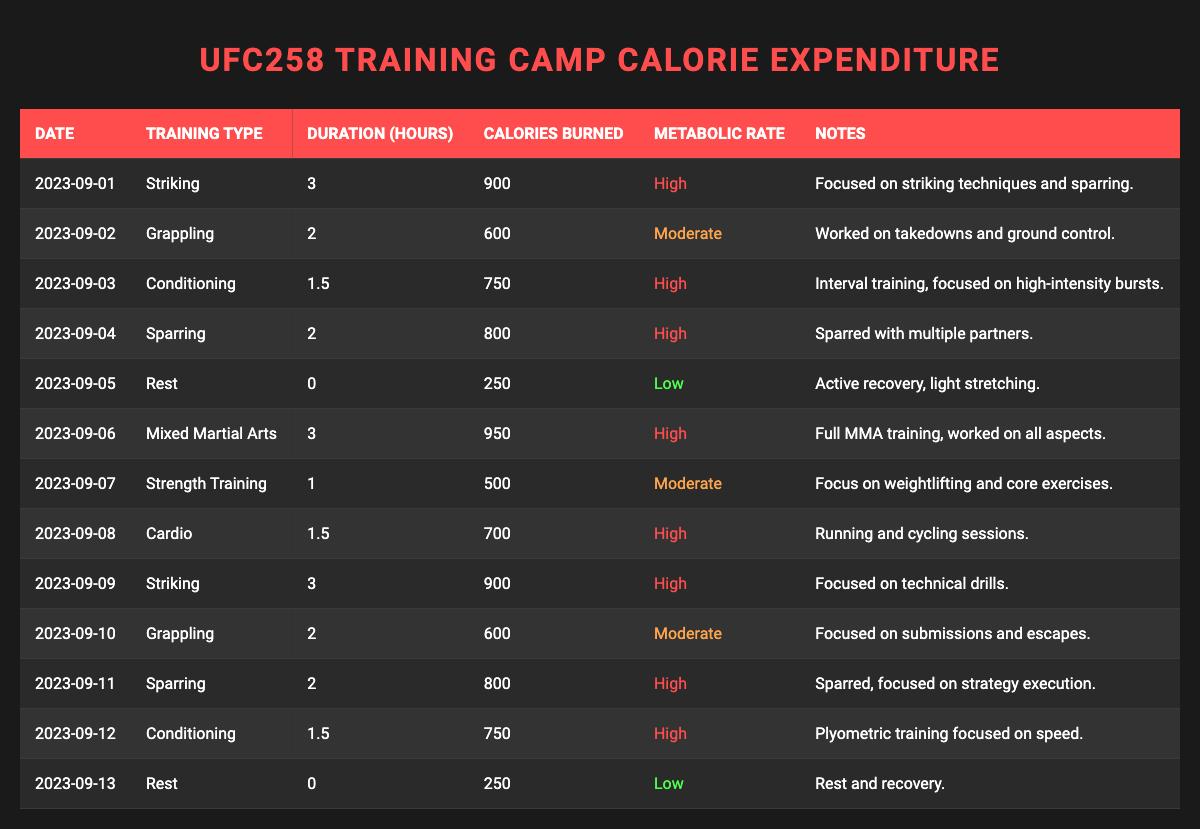What was the total calories burned during the training camp? To find the total calories burned, sum up the "Calories Burned" values for each training session from September 1 to September 13. The total is: 900 + 600 + 750 + 800 + 250 + 950 + 500 + 700 + 900 + 600 + 800 + 750 + 250 = 8550 calories.
Answer: 8550 calories Which training type had the highest calorie expenditure? The "Mixed Martial Arts" training on September 6 had the highest calorie expenditure at 950 calories. No other training session burned more calories than this.
Answer: Mixed Martial Arts How many days involved rest during the training camp? Looking at the "Training Type" column, there are two entries where the training type is "Rest" (September 5 and September 13). Therefore, there were 2 days of rest.
Answer: 2 days What was the average number of calories burned per training day? To calculate the average, sum all calories burned (8550) and divide by the number of training days (11, excluding rest days) which gives us 8550 / 11 ≈ 778.18.
Answer: Approximately 778 calories Did any day involve both high metabolic rate training and rest? No, the table shows that high metabolic rate training sessions occurred on September 1, 3, 4, 6, 8, 9, 11, and 12, while rest days occurred separately on September 5 and 13, indicating no overlap.
Answer: No What is the total duration of high-intensity training sessions in the camp? The total duration of high-intensity sessions includes 3 (Striking) + 1.5 (Conditioning) + 2 (Sparring) + 3 (Mixed Martial Arts) + 1.5 (Cardio) + 3 (Striking) + 2 (Sparring) + 1.5 (Conditioning) = 14.5 hours in high-intensity sessions.
Answer: 14.5 hours Which day had the lowest calories burned and what was the amount? The day with the lowest calories burned was September 5 with 250 calories during a Rest day.
Answer: 250 calories What percentage of the days had a high metabolic rate? There are 8 days with high metabolic rate training out of a total of 13 days (including rest). To get the percentage, (8 / 13) * 100 ≈ 61.54%.
Answer: Approximately 61.5% How many training types were listed in the data, and which one had the lowest calorie expenditure? The training types listed are Striking, Grappling, Conditioning, Sparring, Rest, Mixed Martial Arts, Strength Training, and Cardio, making a total of 8 distinct types. The lowest calorie expenditure was on Rest days with 250 calories.
Answer: 8 types, Rest What was the difference in calories burned between the highest and lowest training sessions? The highest session totaled 950 calories (Mixed Martial Arts) and the lowest was 250 calories (Rest). The difference is 950 - 250 = 700 calories.
Answer: 700 calories 